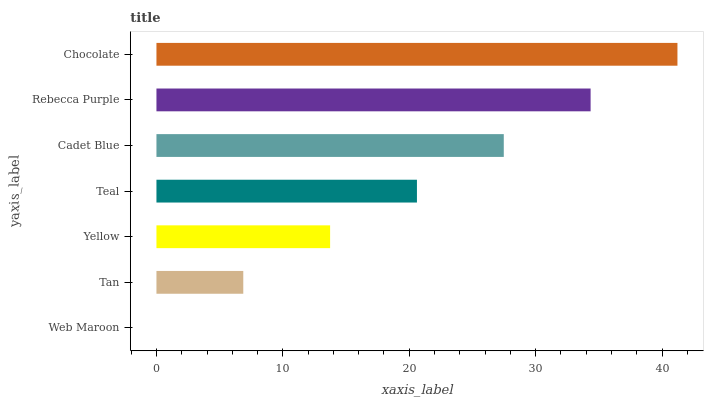Is Web Maroon the minimum?
Answer yes or no. Yes. Is Chocolate the maximum?
Answer yes or no. Yes. Is Tan the minimum?
Answer yes or no. No. Is Tan the maximum?
Answer yes or no. No. Is Tan greater than Web Maroon?
Answer yes or no. Yes. Is Web Maroon less than Tan?
Answer yes or no. Yes. Is Web Maroon greater than Tan?
Answer yes or no. No. Is Tan less than Web Maroon?
Answer yes or no. No. Is Teal the high median?
Answer yes or no. Yes. Is Teal the low median?
Answer yes or no. Yes. Is Web Maroon the high median?
Answer yes or no. No. Is Rebecca Purple the low median?
Answer yes or no. No. 